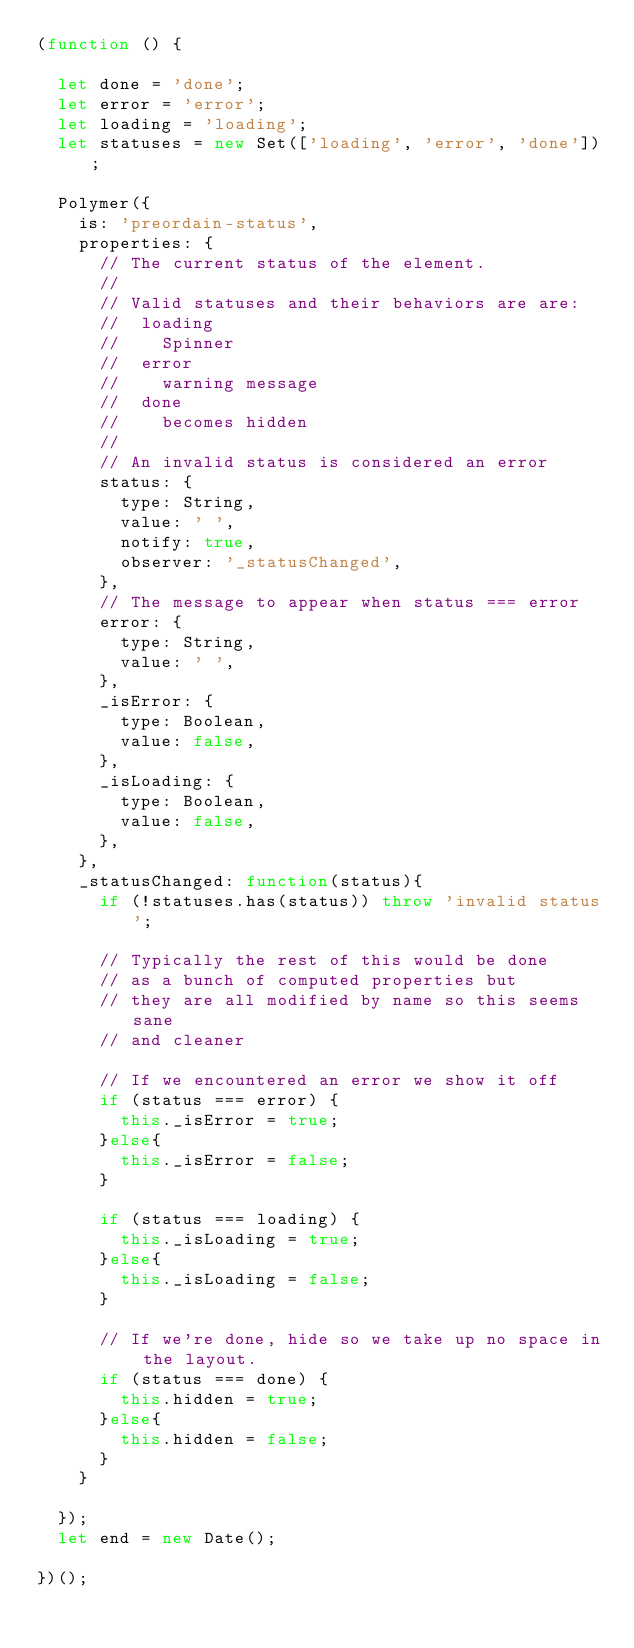Convert code to text. <code><loc_0><loc_0><loc_500><loc_500><_JavaScript_>(function () {

  let done = 'done';
  let error = 'error';
  let loading = 'loading';
  let statuses = new Set(['loading', 'error', 'done']);

  Polymer({
    is: 'preordain-status',
    properties: {
      // The current status of the element.
      //
      // Valid statuses and their behaviors are are:
      //  loading
      //    Spinner
      //  error
      //    warning message 
      //  done
      //    becomes hidden
      //
      // An invalid status is considered an error
      status: {
        type: String,
        value: ' ',
        notify: true,
        observer: '_statusChanged',
      },
      // The message to appear when status === error
      error: {
        type: String,
        value: ' ',
      },
      _isError: {
        type: Boolean,
        value: false,
      },
      _isLoading: {
        type: Boolean,
        value: false,
      },
    },
    _statusChanged: function(status){
      if (!statuses.has(status)) throw 'invalid status';

      // Typically the rest of this would be done
      // as a bunch of computed properties but
      // they are all modified by name so this seems sane
      // and cleaner

      // If we encountered an error we show it off
      if (status === error) {
        this._isError = true;
      }else{
        this._isError = false;
      }

      if (status === loading) {
        this._isLoading = true;
      }else{
        this._isLoading = false;
      }

      // If we're done, hide so we take up no space in the layout.
      if (status === done) {
        this.hidden = true;
      }else{
        this.hidden = false;
      }
    }

  });
  let end = new Date();

})();</code> 